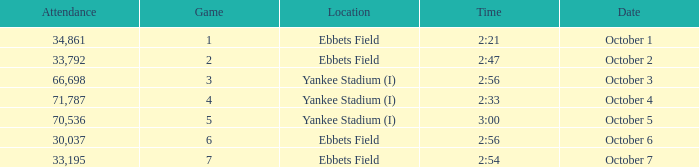Date of October 1 has what average game? 1.0. 